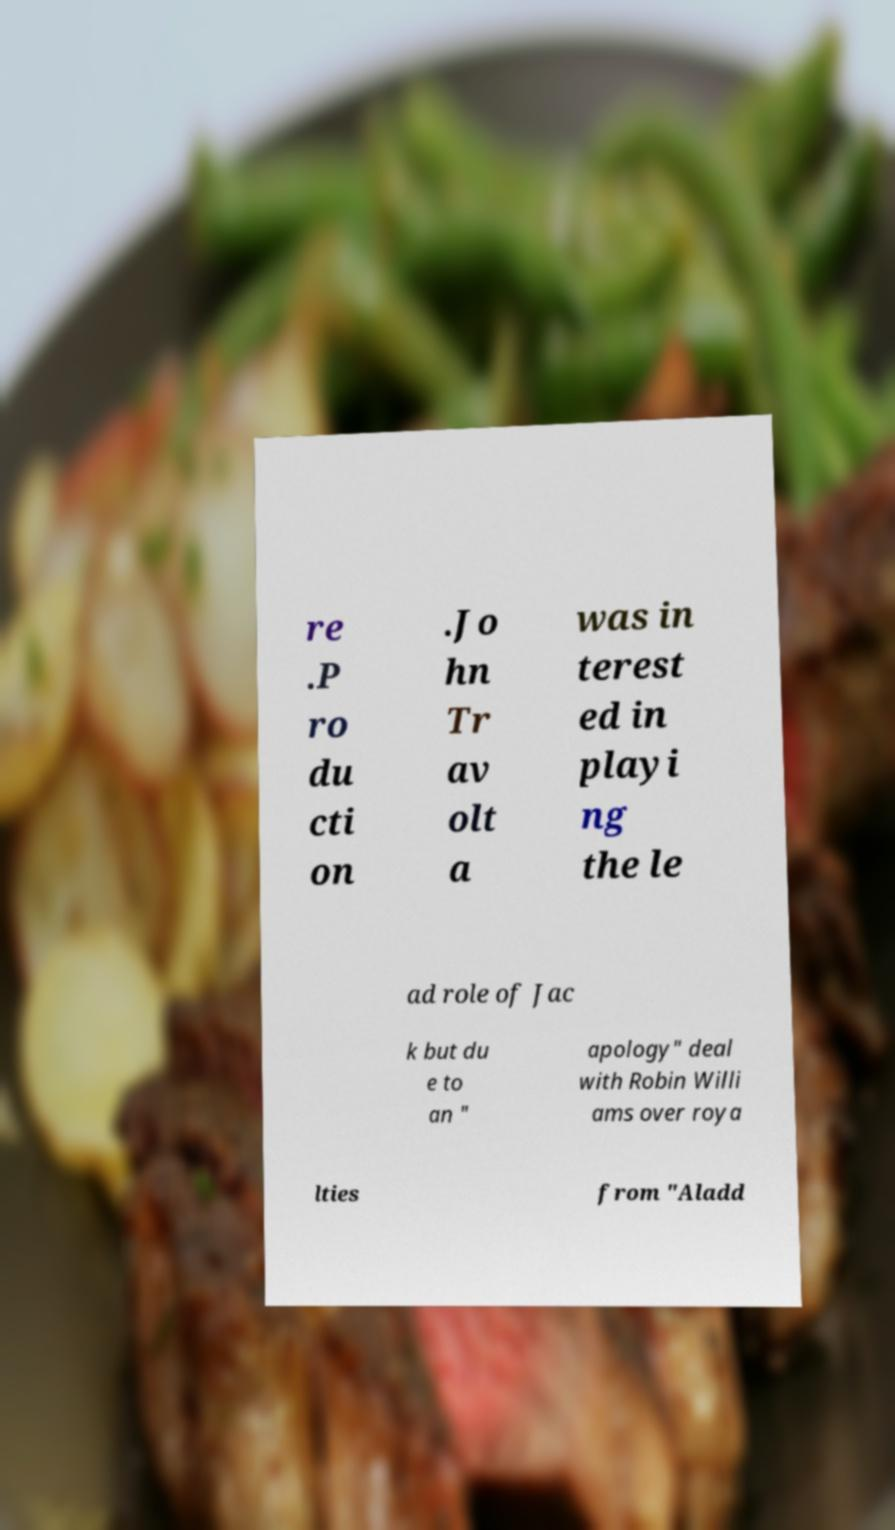Could you extract and type out the text from this image? re .P ro du cti on .Jo hn Tr av olt a was in terest ed in playi ng the le ad role of Jac k but du e to an " apology" deal with Robin Willi ams over roya lties from "Aladd 